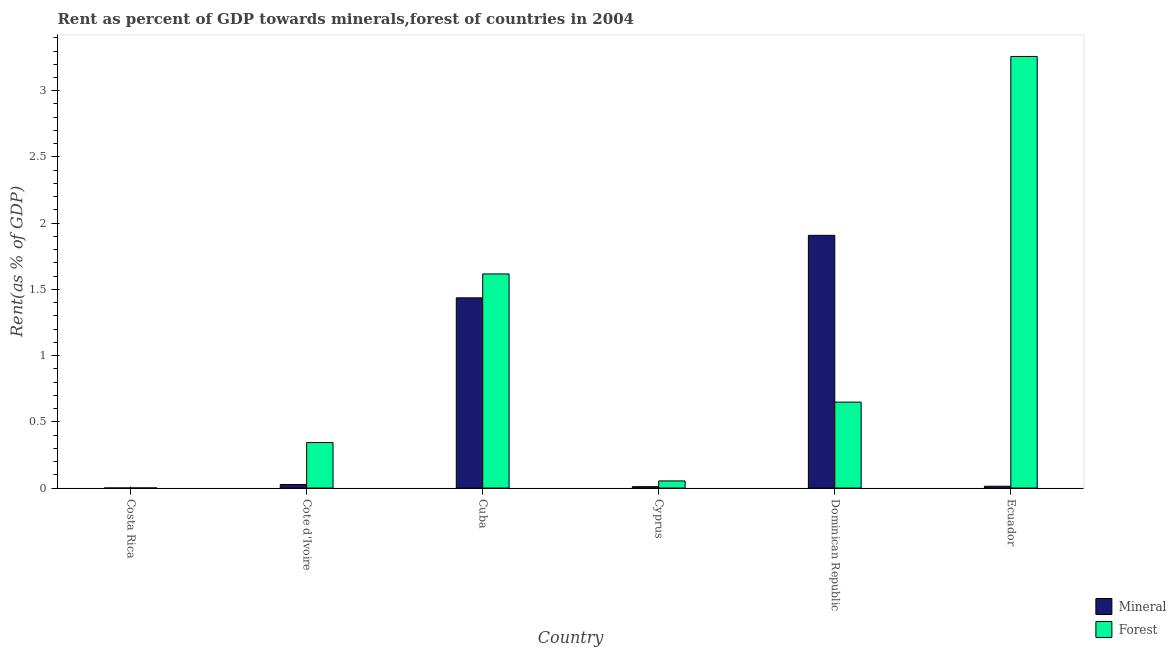How many different coloured bars are there?
Keep it short and to the point. 2. Are the number of bars per tick equal to the number of legend labels?
Give a very brief answer. Yes. Are the number of bars on each tick of the X-axis equal?
Offer a terse response. Yes. How many bars are there on the 6th tick from the left?
Offer a terse response. 2. How many bars are there on the 6th tick from the right?
Offer a very short reply. 2. What is the label of the 4th group of bars from the left?
Ensure brevity in your answer.  Cyprus. What is the mineral rent in Cyprus?
Offer a very short reply. 0.01. Across all countries, what is the maximum mineral rent?
Offer a very short reply. 1.91. Across all countries, what is the minimum mineral rent?
Your response must be concise. 0. In which country was the mineral rent maximum?
Offer a terse response. Dominican Republic. What is the total mineral rent in the graph?
Offer a terse response. 3.4. What is the difference between the forest rent in Costa Rica and that in Dominican Republic?
Provide a short and direct response. -0.65. What is the difference between the mineral rent in Cuba and the forest rent in Cyprus?
Offer a terse response. 1.38. What is the average forest rent per country?
Your answer should be very brief. 0.99. What is the difference between the forest rent and mineral rent in Costa Rica?
Offer a terse response. 0. What is the ratio of the forest rent in Cuba to that in Dominican Republic?
Keep it short and to the point. 2.49. Is the difference between the forest rent in Costa Rica and Cyprus greater than the difference between the mineral rent in Costa Rica and Cyprus?
Your answer should be compact. No. What is the difference between the highest and the second highest forest rent?
Keep it short and to the point. 1.64. What is the difference between the highest and the lowest mineral rent?
Offer a terse response. 1.91. In how many countries, is the mineral rent greater than the average mineral rent taken over all countries?
Provide a succinct answer. 2. Is the sum of the forest rent in Costa Rica and Cyprus greater than the maximum mineral rent across all countries?
Make the answer very short. No. What does the 1st bar from the left in Dominican Republic represents?
Ensure brevity in your answer.  Mineral. What does the 1st bar from the right in Dominican Republic represents?
Provide a succinct answer. Forest. Does the graph contain grids?
Give a very brief answer. No. Where does the legend appear in the graph?
Provide a succinct answer. Bottom right. What is the title of the graph?
Provide a succinct answer. Rent as percent of GDP towards minerals,forest of countries in 2004. Does "Merchandise exports" appear as one of the legend labels in the graph?
Make the answer very short. No. What is the label or title of the X-axis?
Make the answer very short. Country. What is the label or title of the Y-axis?
Give a very brief answer. Rent(as % of GDP). What is the Rent(as % of GDP) of Mineral in Costa Rica?
Your answer should be very brief. 0. What is the Rent(as % of GDP) in Forest in Costa Rica?
Your answer should be very brief. 0. What is the Rent(as % of GDP) of Mineral in Cote d'Ivoire?
Your answer should be very brief. 0.03. What is the Rent(as % of GDP) in Forest in Cote d'Ivoire?
Give a very brief answer. 0.34. What is the Rent(as % of GDP) of Mineral in Cuba?
Offer a very short reply. 1.44. What is the Rent(as % of GDP) in Forest in Cuba?
Your response must be concise. 1.62. What is the Rent(as % of GDP) in Mineral in Cyprus?
Your response must be concise. 0.01. What is the Rent(as % of GDP) of Forest in Cyprus?
Provide a short and direct response. 0.05. What is the Rent(as % of GDP) in Mineral in Dominican Republic?
Make the answer very short. 1.91. What is the Rent(as % of GDP) of Forest in Dominican Republic?
Offer a terse response. 0.65. What is the Rent(as % of GDP) of Mineral in Ecuador?
Give a very brief answer. 0.01. What is the Rent(as % of GDP) in Forest in Ecuador?
Provide a short and direct response. 3.26. Across all countries, what is the maximum Rent(as % of GDP) of Mineral?
Make the answer very short. 1.91. Across all countries, what is the maximum Rent(as % of GDP) in Forest?
Offer a very short reply. 3.26. Across all countries, what is the minimum Rent(as % of GDP) in Mineral?
Keep it short and to the point. 0. Across all countries, what is the minimum Rent(as % of GDP) in Forest?
Provide a succinct answer. 0. What is the total Rent(as % of GDP) of Mineral in the graph?
Your response must be concise. 3.4. What is the total Rent(as % of GDP) in Forest in the graph?
Give a very brief answer. 5.92. What is the difference between the Rent(as % of GDP) in Mineral in Costa Rica and that in Cote d'Ivoire?
Provide a succinct answer. -0.03. What is the difference between the Rent(as % of GDP) in Forest in Costa Rica and that in Cote d'Ivoire?
Offer a very short reply. -0.34. What is the difference between the Rent(as % of GDP) in Mineral in Costa Rica and that in Cuba?
Offer a very short reply. -1.44. What is the difference between the Rent(as % of GDP) in Forest in Costa Rica and that in Cuba?
Ensure brevity in your answer.  -1.62. What is the difference between the Rent(as % of GDP) of Mineral in Costa Rica and that in Cyprus?
Your answer should be very brief. -0.01. What is the difference between the Rent(as % of GDP) of Forest in Costa Rica and that in Cyprus?
Make the answer very short. -0.05. What is the difference between the Rent(as % of GDP) of Mineral in Costa Rica and that in Dominican Republic?
Ensure brevity in your answer.  -1.91. What is the difference between the Rent(as % of GDP) in Forest in Costa Rica and that in Dominican Republic?
Your response must be concise. -0.65. What is the difference between the Rent(as % of GDP) of Mineral in Costa Rica and that in Ecuador?
Ensure brevity in your answer.  -0.01. What is the difference between the Rent(as % of GDP) of Forest in Costa Rica and that in Ecuador?
Offer a very short reply. -3.26. What is the difference between the Rent(as % of GDP) of Mineral in Cote d'Ivoire and that in Cuba?
Offer a very short reply. -1.41. What is the difference between the Rent(as % of GDP) of Forest in Cote d'Ivoire and that in Cuba?
Ensure brevity in your answer.  -1.27. What is the difference between the Rent(as % of GDP) of Mineral in Cote d'Ivoire and that in Cyprus?
Offer a terse response. 0.02. What is the difference between the Rent(as % of GDP) of Forest in Cote d'Ivoire and that in Cyprus?
Provide a succinct answer. 0.29. What is the difference between the Rent(as % of GDP) of Mineral in Cote d'Ivoire and that in Dominican Republic?
Ensure brevity in your answer.  -1.88. What is the difference between the Rent(as % of GDP) of Forest in Cote d'Ivoire and that in Dominican Republic?
Offer a terse response. -0.31. What is the difference between the Rent(as % of GDP) of Mineral in Cote d'Ivoire and that in Ecuador?
Provide a succinct answer. 0.01. What is the difference between the Rent(as % of GDP) of Forest in Cote d'Ivoire and that in Ecuador?
Make the answer very short. -2.92. What is the difference between the Rent(as % of GDP) in Mineral in Cuba and that in Cyprus?
Provide a short and direct response. 1.43. What is the difference between the Rent(as % of GDP) in Forest in Cuba and that in Cyprus?
Your answer should be compact. 1.56. What is the difference between the Rent(as % of GDP) of Mineral in Cuba and that in Dominican Republic?
Make the answer very short. -0.47. What is the difference between the Rent(as % of GDP) of Forest in Cuba and that in Dominican Republic?
Offer a very short reply. 0.97. What is the difference between the Rent(as % of GDP) in Mineral in Cuba and that in Ecuador?
Offer a very short reply. 1.42. What is the difference between the Rent(as % of GDP) in Forest in Cuba and that in Ecuador?
Ensure brevity in your answer.  -1.64. What is the difference between the Rent(as % of GDP) of Mineral in Cyprus and that in Dominican Republic?
Offer a very short reply. -1.9. What is the difference between the Rent(as % of GDP) in Forest in Cyprus and that in Dominican Republic?
Give a very brief answer. -0.59. What is the difference between the Rent(as % of GDP) in Mineral in Cyprus and that in Ecuador?
Your answer should be very brief. -0. What is the difference between the Rent(as % of GDP) in Forest in Cyprus and that in Ecuador?
Give a very brief answer. -3.2. What is the difference between the Rent(as % of GDP) in Mineral in Dominican Republic and that in Ecuador?
Make the answer very short. 1.89. What is the difference between the Rent(as % of GDP) of Forest in Dominican Republic and that in Ecuador?
Give a very brief answer. -2.61. What is the difference between the Rent(as % of GDP) of Mineral in Costa Rica and the Rent(as % of GDP) of Forest in Cote d'Ivoire?
Offer a very short reply. -0.34. What is the difference between the Rent(as % of GDP) in Mineral in Costa Rica and the Rent(as % of GDP) in Forest in Cuba?
Ensure brevity in your answer.  -1.62. What is the difference between the Rent(as % of GDP) in Mineral in Costa Rica and the Rent(as % of GDP) in Forest in Cyprus?
Offer a very short reply. -0.05. What is the difference between the Rent(as % of GDP) in Mineral in Costa Rica and the Rent(as % of GDP) in Forest in Dominican Republic?
Provide a succinct answer. -0.65. What is the difference between the Rent(as % of GDP) of Mineral in Costa Rica and the Rent(as % of GDP) of Forest in Ecuador?
Offer a very short reply. -3.26. What is the difference between the Rent(as % of GDP) of Mineral in Cote d'Ivoire and the Rent(as % of GDP) of Forest in Cuba?
Provide a short and direct response. -1.59. What is the difference between the Rent(as % of GDP) in Mineral in Cote d'Ivoire and the Rent(as % of GDP) in Forest in Cyprus?
Make the answer very short. -0.03. What is the difference between the Rent(as % of GDP) of Mineral in Cote d'Ivoire and the Rent(as % of GDP) of Forest in Dominican Republic?
Make the answer very short. -0.62. What is the difference between the Rent(as % of GDP) of Mineral in Cote d'Ivoire and the Rent(as % of GDP) of Forest in Ecuador?
Offer a terse response. -3.23. What is the difference between the Rent(as % of GDP) in Mineral in Cuba and the Rent(as % of GDP) in Forest in Cyprus?
Offer a very short reply. 1.38. What is the difference between the Rent(as % of GDP) of Mineral in Cuba and the Rent(as % of GDP) of Forest in Dominican Republic?
Provide a succinct answer. 0.79. What is the difference between the Rent(as % of GDP) in Mineral in Cuba and the Rent(as % of GDP) in Forest in Ecuador?
Offer a very short reply. -1.82. What is the difference between the Rent(as % of GDP) in Mineral in Cyprus and the Rent(as % of GDP) in Forest in Dominican Republic?
Your answer should be very brief. -0.64. What is the difference between the Rent(as % of GDP) of Mineral in Cyprus and the Rent(as % of GDP) of Forest in Ecuador?
Offer a very short reply. -3.25. What is the difference between the Rent(as % of GDP) of Mineral in Dominican Republic and the Rent(as % of GDP) of Forest in Ecuador?
Offer a very short reply. -1.35. What is the average Rent(as % of GDP) of Mineral per country?
Ensure brevity in your answer.  0.57. What is the average Rent(as % of GDP) in Forest per country?
Give a very brief answer. 0.99. What is the difference between the Rent(as % of GDP) in Mineral and Rent(as % of GDP) in Forest in Costa Rica?
Provide a succinct answer. -0. What is the difference between the Rent(as % of GDP) in Mineral and Rent(as % of GDP) in Forest in Cote d'Ivoire?
Offer a very short reply. -0.32. What is the difference between the Rent(as % of GDP) of Mineral and Rent(as % of GDP) of Forest in Cuba?
Provide a short and direct response. -0.18. What is the difference between the Rent(as % of GDP) of Mineral and Rent(as % of GDP) of Forest in Cyprus?
Make the answer very short. -0.04. What is the difference between the Rent(as % of GDP) of Mineral and Rent(as % of GDP) of Forest in Dominican Republic?
Ensure brevity in your answer.  1.26. What is the difference between the Rent(as % of GDP) of Mineral and Rent(as % of GDP) of Forest in Ecuador?
Ensure brevity in your answer.  -3.25. What is the ratio of the Rent(as % of GDP) in Mineral in Costa Rica to that in Cote d'Ivoire?
Your answer should be very brief. 0.03. What is the ratio of the Rent(as % of GDP) of Forest in Costa Rica to that in Cote d'Ivoire?
Your answer should be compact. 0. What is the ratio of the Rent(as % of GDP) in Mineral in Costa Rica to that in Cuba?
Your response must be concise. 0. What is the ratio of the Rent(as % of GDP) of Forest in Costa Rica to that in Cuba?
Provide a succinct answer. 0. What is the ratio of the Rent(as % of GDP) in Mineral in Costa Rica to that in Cyprus?
Your answer should be compact. 0.08. What is the ratio of the Rent(as % of GDP) in Forest in Costa Rica to that in Cyprus?
Provide a short and direct response. 0.02. What is the ratio of the Rent(as % of GDP) of Forest in Costa Rica to that in Dominican Republic?
Ensure brevity in your answer.  0. What is the ratio of the Rent(as % of GDP) of Mineral in Costa Rica to that in Ecuador?
Your answer should be very brief. 0.06. What is the ratio of the Rent(as % of GDP) of Mineral in Cote d'Ivoire to that in Cuba?
Your answer should be very brief. 0.02. What is the ratio of the Rent(as % of GDP) of Forest in Cote d'Ivoire to that in Cuba?
Keep it short and to the point. 0.21. What is the ratio of the Rent(as % of GDP) of Mineral in Cote d'Ivoire to that in Cyprus?
Your response must be concise. 2.53. What is the ratio of the Rent(as % of GDP) of Forest in Cote d'Ivoire to that in Cyprus?
Your response must be concise. 6.35. What is the ratio of the Rent(as % of GDP) of Mineral in Cote d'Ivoire to that in Dominican Republic?
Provide a succinct answer. 0.01. What is the ratio of the Rent(as % of GDP) in Forest in Cote d'Ivoire to that in Dominican Republic?
Provide a short and direct response. 0.53. What is the ratio of the Rent(as % of GDP) in Mineral in Cote d'Ivoire to that in Ecuador?
Ensure brevity in your answer.  1.96. What is the ratio of the Rent(as % of GDP) of Forest in Cote d'Ivoire to that in Ecuador?
Offer a terse response. 0.11. What is the ratio of the Rent(as % of GDP) in Mineral in Cuba to that in Cyprus?
Your response must be concise. 133.76. What is the ratio of the Rent(as % of GDP) of Forest in Cuba to that in Cyprus?
Offer a very short reply. 29.88. What is the ratio of the Rent(as % of GDP) of Mineral in Cuba to that in Dominican Republic?
Make the answer very short. 0.75. What is the ratio of the Rent(as % of GDP) in Forest in Cuba to that in Dominican Republic?
Provide a short and direct response. 2.49. What is the ratio of the Rent(as % of GDP) in Mineral in Cuba to that in Ecuador?
Offer a terse response. 103.74. What is the ratio of the Rent(as % of GDP) of Forest in Cuba to that in Ecuador?
Provide a short and direct response. 0.5. What is the ratio of the Rent(as % of GDP) in Mineral in Cyprus to that in Dominican Republic?
Provide a short and direct response. 0.01. What is the ratio of the Rent(as % of GDP) in Forest in Cyprus to that in Dominican Republic?
Your response must be concise. 0.08. What is the ratio of the Rent(as % of GDP) of Mineral in Cyprus to that in Ecuador?
Offer a terse response. 0.78. What is the ratio of the Rent(as % of GDP) of Forest in Cyprus to that in Ecuador?
Provide a short and direct response. 0.02. What is the ratio of the Rent(as % of GDP) of Mineral in Dominican Republic to that in Ecuador?
Ensure brevity in your answer.  137.8. What is the ratio of the Rent(as % of GDP) of Forest in Dominican Republic to that in Ecuador?
Ensure brevity in your answer.  0.2. What is the difference between the highest and the second highest Rent(as % of GDP) of Mineral?
Keep it short and to the point. 0.47. What is the difference between the highest and the second highest Rent(as % of GDP) of Forest?
Give a very brief answer. 1.64. What is the difference between the highest and the lowest Rent(as % of GDP) of Mineral?
Your answer should be compact. 1.91. What is the difference between the highest and the lowest Rent(as % of GDP) of Forest?
Provide a short and direct response. 3.26. 